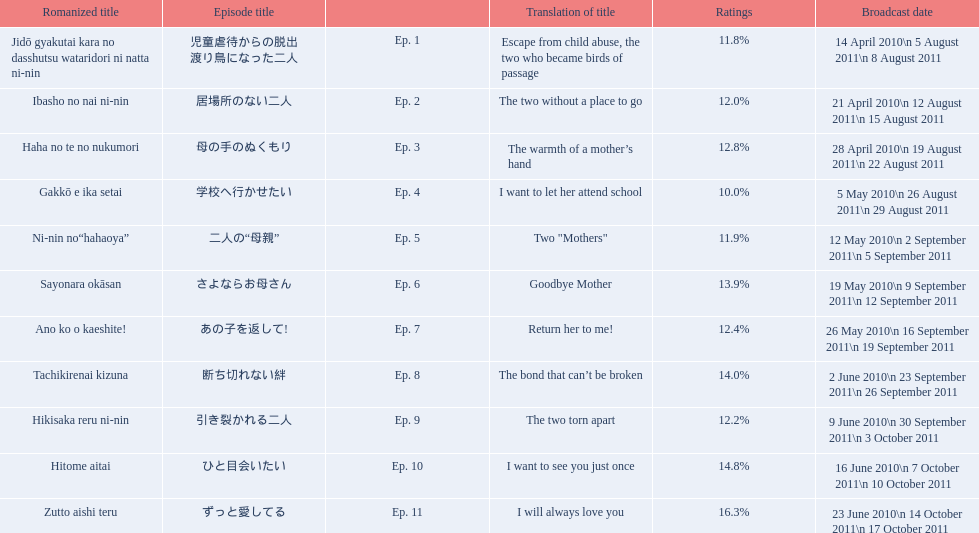What are the episode numbers? Ep. 1, Ep. 2, Ep. 3, Ep. 4, Ep. 5, Ep. 6, Ep. 7, Ep. 8, Ep. 9, Ep. 10, Ep. 11. What was the percentage of total ratings for episode 8? 14.0%. 